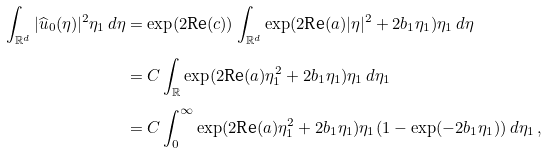Convert formula to latex. <formula><loc_0><loc_0><loc_500><loc_500>\int _ { \mathbb { R } ^ { d } } | \widehat { u } _ { 0 } ( \eta ) | ^ { 2 } \eta _ { 1 } \, d \eta & = \exp ( 2 \text {Re} ( c ) ) \int _ { \mathbb { R } ^ { d } } \exp ( 2 \text {Re} ( a ) | \eta | ^ { 2 } + 2 b _ { 1 } \eta _ { 1 } ) \eta _ { 1 } \, d \eta \\ & = C \int _ { \mathbb { R } } \exp ( 2 \text {Re} ( a ) \eta _ { 1 } ^ { 2 } + 2 b _ { 1 } \eta _ { 1 } ) \eta _ { 1 } \, d \eta _ { 1 } \\ & = C \int _ { 0 } ^ { \infty } \exp ( 2 \text {Re} ( a ) \eta _ { 1 } ^ { 2 } + 2 b _ { 1 } \eta _ { 1 } ) \eta _ { 1 } ( 1 - \exp ( - 2 b _ { 1 } \eta _ { 1 } ) ) \, d \eta _ { 1 } \, ,</formula> 